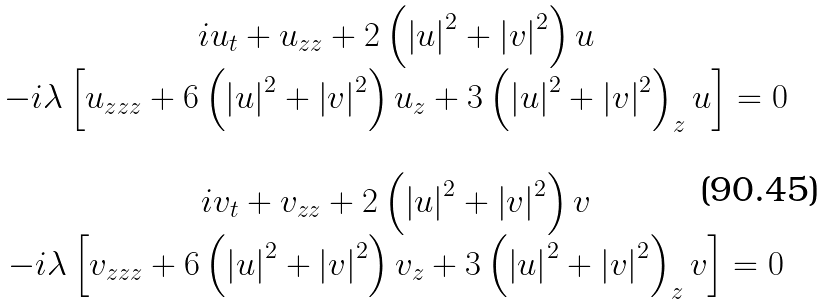<formula> <loc_0><loc_0><loc_500><loc_500>\begin{array} { c } i u _ { t } + u _ { z z } + 2 \left ( \left | u \right | ^ { 2 } + \left | v \right | ^ { 2 } \right ) u \\ - i \lambda \left [ u _ { z z z } + 6 \left ( \left | u \right | ^ { 2 } + \left | v \right | ^ { 2 } \right ) u _ { z } + 3 \left ( \left | u \right | ^ { 2 } + \left | v \right | ^ { 2 } \right ) _ { z } u \right ] = 0 \\ \\ i v _ { t } + v _ { z z } + 2 \left ( \left | u \right | ^ { 2 } + \left | v \right | ^ { 2 } \right ) v \\ - i \lambda \left [ v _ { z z z } + 6 \left ( \left | u \right | ^ { 2 } + \left | v \right | ^ { 2 } \right ) v _ { z } + 3 \left ( \left | u \right | ^ { 2 } + \left | v \right | ^ { 2 } \right ) _ { z } v \right ] = 0 \end{array}</formula> 